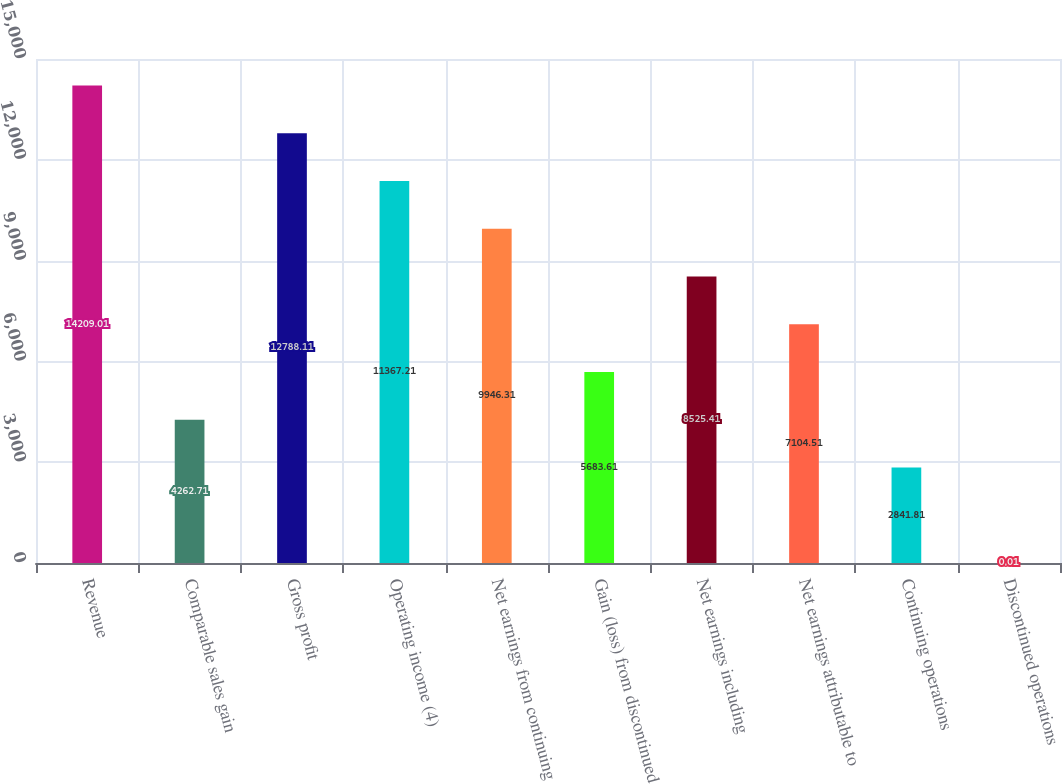<chart> <loc_0><loc_0><loc_500><loc_500><bar_chart><fcel>Revenue<fcel>Comparable sales gain<fcel>Gross profit<fcel>Operating income (4)<fcel>Net earnings from continuing<fcel>Gain (loss) from discontinued<fcel>Net earnings including<fcel>Net earnings attributable to<fcel>Continuing operations<fcel>Discontinued operations<nl><fcel>14209<fcel>4262.71<fcel>12788.1<fcel>11367.2<fcel>9946.31<fcel>5683.61<fcel>8525.41<fcel>7104.51<fcel>2841.81<fcel>0.01<nl></chart> 